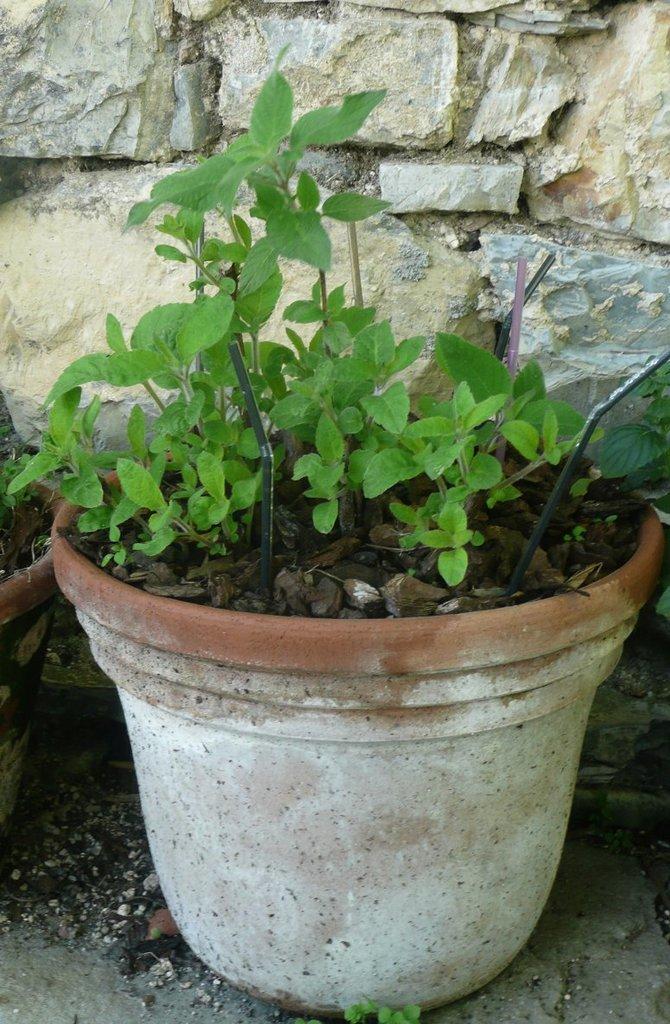Describe this image in one or two sentences. In this image we can see two flower pots with plants placed on a surface. In the background, we can see the wall with stones. 